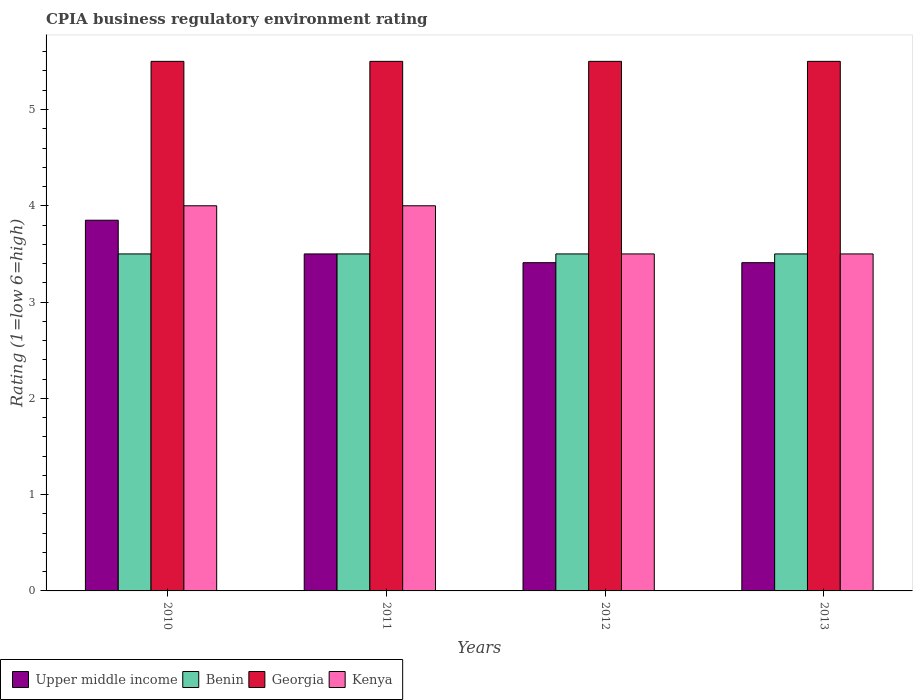Are the number of bars per tick equal to the number of legend labels?
Your answer should be compact. Yes. How many bars are there on the 3rd tick from the right?
Your answer should be very brief. 4. In how many cases, is the number of bars for a given year not equal to the number of legend labels?
Offer a terse response. 0. What is the CPIA rating in Upper middle income in 2010?
Your response must be concise. 3.85. Across all years, what is the maximum CPIA rating in Upper middle income?
Offer a terse response. 3.85. Across all years, what is the minimum CPIA rating in Georgia?
Give a very brief answer. 5.5. In which year was the CPIA rating in Upper middle income minimum?
Your answer should be compact. 2012. What is the total CPIA rating in Upper middle income in the graph?
Your answer should be very brief. 14.17. What is the difference between the CPIA rating in Upper middle income in 2010 and that in 2011?
Your answer should be compact. 0.35. What is the difference between the CPIA rating in Georgia in 2010 and the CPIA rating in Benin in 2013?
Your answer should be very brief. 2. What is the average CPIA rating in Kenya per year?
Your response must be concise. 3.75. In the year 2013, what is the difference between the CPIA rating in Georgia and CPIA rating in Upper middle income?
Ensure brevity in your answer.  2.09. In how many years, is the CPIA rating in Benin greater than 2.8?
Your answer should be compact. 4. Is the CPIA rating in Kenya in 2012 less than that in 2013?
Provide a succinct answer. No. Is the difference between the CPIA rating in Georgia in 2010 and 2013 greater than the difference between the CPIA rating in Upper middle income in 2010 and 2013?
Provide a short and direct response. No. What is the difference between the highest and the second highest CPIA rating in Benin?
Provide a succinct answer. 0. In how many years, is the CPIA rating in Georgia greater than the average CPIA rating in Georgia taken over all years?
Offer a terse response. 0. Is the sum of the CPIA rating in Upper middle income in 2010 and 2011 greater than the maximum CPIA rating in Kenya across all years?
Provide a short and direct response. Yes. What does the 4th bar from the left in 2012 represents?
Ensure brevity in your answer.  Kenya. What does the 1st bar from the right in 2012 represents?
Offer a terse response. Kenya. Where does the legend appear in the graph?
Your answer should be very brief. Bottom left. How many legend labels are there?
Keep it short and to the point. 4. What is the title of the graph?
Give a very brief answer. CPIA business regulatory environment rating. What is the Rating (1=low 6=high) of Upper middle income in 2010?
Keep it short and to the point. 3.85. What is the Rating (1=low 6=high) of Kenya in 2010?
Your answer should be compact. 4. What is the Rating (1=low 6=high) in Upper middle income in 2012?
Give a very brief answer. 3.41. What is the Rating (1=low 6=high) of Georgia in 2012?
Make the answer very short. 5.5. What is the Rating (1=low 6=high) of Kenya in 2012?
Provide a short and direct response. 3.5. What is the Rating (1=low 6=high) of Upper middle income in 2013?
Offer a terse response. 3.41. What is the Rating (1=low 6=high) in Benin in 2013?
Your response must be concise. 3.5. Across all years, what is the maximum Rating (1=low 6=high) of Upper middle income?
Keep it short and to the point. 3.85. Across all years, what is the maximum Rating (1=low 6=high) in Benin?
Keep it short and to the point. 3.5. Across all years, what is the minimum Rating (1=low 6=high) in Upper middle income?
Your response must be concise. 3.41. Across all years, what is the minimum Rating (1=low 6=high) of Kenya?
Keep it short and to the point. 3.5. What is the total Rating (1=low 6=high) of Upper middle income in the graph?
Give a very brief answer. 14.17. What is the total Rating (1=low 6=high) of Georgia in the graph?
Give a very brief answer. 22. What is the total Rating (1=low 6=high) of Kenya in the graph?
Offer a terse response. 15. What is the difference between the Rating (1=low 6=high) in Benin in 2010 and that in 2011?
Your answer should be compact. 0. What is the difference between the Rating (1=low 6=high) in Georgia in 2010 and that in 2011?
Offer a terse response. 0. What is the difference between the Rating (1=low 6=high) of Kenya in 2010 and that in 2011?
Keep it short and to the point. 0. What is the difference between the Rating (1=low 6=high) in Upper middle income in 2010 and that in 2012?
Offer a very short reply. 0.44. What is the difference between the Rating (1=low 6=high) in Benin in 2010 and that in 2012?
Keep it short and to the point. 0. What is the difference between the Rating (1=low 6=high) of Georgia in 2010 and that in 2012?
Offer a terse response. 0. What is the difference between the Rating (1=low 6=high) in Upper middle income in 2010 and that in 2013?
Offer a very short reply. 0.44. What is the difference between the Rating (1=low 6=high) of Kenya in 2010 and that in 2013?
Your response must be concise. 0.5. What is the difference between the Rating (1=low 6=high) of Upper middle income in 2011 and that in 2012?
Make the answer very short. 0.09. What is the difference between the Rating (1=low 6=high) in Georgia in 2011 and that in 2012?
Offer a terse response. 0. What is the difference between the Rating (1=low 6=high) of Upper middle income in 2011 and that in 2013?
Keep it short and to the point. 0.09. What is the difference between the Rating (1=low 6=high) in Benin in 2011 and that in 2013?
Your answer should be compact. 0. What is the difference between the Rating (1=low 6=high) in Georgia in 2011 and that in 2013?
Your response must be concise. 0. What is the difference between the Rating (1=low 6=high) of Kenya in 2011 and that in 2013?
Offer a very short reply. 0.5. What is the difference between the Rating (1=low 6=high) of Georgia in 2012 and that in 2013?
Keep it short and to the point. 0. What is the difference between the Rating (1=low 6=high) of Kenya in 2012 and that in 2013?
Provide a succinct answer. 0. What is the difference between the Rating (1=low 6=high) in Upper middle income in 2010 and the Rating (1=low 6=high) in Georgia in 2011?
Your answer should be compact. -1.65. What is the difference between the Rating (1=low 6=high) in Upper middle income in 2010 and the Rating (1=low 6=high) in Kenya in 2011?
Ensure brevity in your answer.  -0.15. What is the difference between the Rating (1=low 6=high) in Benin in 2010 and the Rating (1=low 6=high) in Kenya in 2011?
Offer a terse response. -0.5. What is the difference between the Rating (1=low 6=high) in Georgia in 2010 and the Rating (1=low 6=high) in Kenya in 2011?
Your response must be concise. 1.5. What is the difference between the Rating (1=low 6=high) of Upper middle income in 2010 and the Rating (1=low 6=high) of Benin in 2012?
Ensure brevity in your answer.  0.35. What is the difference between the Rating (1=low 6=high) in Upper middle income in 2010 and the Rating (1=low 6=high) in Georgia in 2012?
Provide a short and direct response. -1.65. What is the difference between the Rating (1=low 6=high) in Benin in 2010 and the Rating (1=low 6=high) in Kenya in 2012?
Your answer should be very brief. 0. What is the difference between the Rating (1=low 6=high) in Georgia in 2010 and the Rating (1=low 6=high) in Kenya in 2012?
Your answer should be very brief. 2. What is the difference between the Rating (1=low 6=high) in Upper middle income in 2010 and the Rating (1=low 6=high) in Georgia in 2013?
Offer a very short reply. -1.65. What is the difference between the Rating (1=low 6=high) in Upper middle income in 2010 and the Rating (1=low 6=high) in Kenya in 2013?
Your answer should be very brief. 0.35. What is the difference between the Rating (1=low 6=high) of Benin in 2010 and the Rating (1=low 6=high) of Georgia in 2013?
Give a very brief answer. -2. What is the difference between the Rating (1=low 6=high) in Upper middle income in 2011 and the Rating (1=low 6=high) in Benin in 2012?
Give a very brief answer. 0. What is the difference between the Rating (1=low 6=high) in Upper middle income in 2011 and the Rating (1=low 6=high) in Georgia in 2012?
Your response must be concise. -2. What is the difference between the Rating (1=low 6=high) in Benin in 2011 and the Rating (1=low 6=high) in Georgia in 2012?
Offer a very short reply. -2. What is the difference between the Rating (1=low 6=high) in Benin in 2011 and the Rating (1=low 6=high) in Kenya in 2012?
Provide a short and direct response. 0. What is the difference between the Rating (1=low 6=high) of Upper middle income in 2011 and the Rating (1=low 6=high) of Benin in 2013?
Make the answer very short. 0. What is the difference between the Rating (1=low 6=high) of Upper middle income in 2012 and the Rating (1=low 6=high) of Benin in 2013?
Your answer should be compact. -0.09. What is the difference between the Rating (1=low 6=high) of Upper middle income in 2012 and the Rating (1=low 6=high) of Georgia in 2013?
Keep it short and to the point. -2.09. What is the difference between the Rating (1=low 6=high) of Upper middle income in 2012 and the Rating (1=low 6=high) of Kenya in 2013?
Give a very brief answer. -0.09. What is the difference between the Rating (1=low 6=high) in Benin in 2012 and the Rating (1=low 6=high) in Kenya in 2013?
Give a very brief answer. 0. What is the average Rating (1=low 6=high) of Upper middle income per year?
Keep it short and to the point. 3.54. What is the average Rating (1=low 6=high) in Kenya per year?
Offer a terse response. 3.75. In the year 2010, what is the difference between the Rating (1=low 6=high) in Upper middle income and Rating (1=low 6=high) in Benin?
Your answer should be compact. 0.35. In the year 2010, what is the difference between the Rating (1=low 6=high) of Upper middle income and Rating (1=low 6=high) of Georgia?
Give a very brief answer. -1.65. In the year 2010, what is the difference between the Rating (1=low 6=high) of Benin and Rating (1=low 6=high) of Kenya?
Keep it short and to the point. -0.5. In the year 2011, what is the difference between the Rating (1=low 6=high) of Upper middle income and Rating (1=low 6=high) of Georgia?
Offer a terse response. -2. In the year 2011, what is the difference between the Rating (1=low 6=high) of Upper middle income and Rating (1=low 6=high) of Kenya?
Your answer should be compact. -0.5. In the year 2011, what is the difference between the Rating (1=low 6=high) in Benin and Rating (1=low 6=high) in Georgia?
Provide a short and direct response. -2. In the year 2011, what is the difference between the Rating (1=low 6=high) of Benin and Rating (1=low 6=high) of Kenya?
Offer a terse response. -0.5. In the year 2012, what is the difference between the Rating (1=low 6=high) of Upper middle income and Rating (1=low 6=high) of Benin?
Make the answer very short. -0.09. In the year 2012, what is the difference between the Rating (1=low 6=high) in Upper middle income and Rating (1=low 6=high) in Georgia?
Provide a succinct answer. -2.09. In the year 2012, what is the difference between the Rating (1=low 6=high) in Upper middle income and Rating (1=low 6=high) in Kenya?
Offer a very short reply. -0.09. In the year 2013, what is the difference between the Rating (1=low 6=high) of Upper middle income and Rating (1=low 6=high) of Benin?
Give a very brief answer. -0.09. In the year 2013, what is the difference between the Rating (1=low 6=high) in Upper middle income and Rating (1=low 6=high) in Georgia?
Provide a short and direct response. -2.09. In the year 2013, what is the difference between the Rating (1=low 6=high) in Upper middle income and Rating (1=low 6=high) in Kenya?
Ensure brevity in your answer.  -0.09. In the year 2013, what is the difference between the Rating (1=low 6=high) of Benin and Rating (1=low 6=high) of Kenya?
Give a very brief answer. 0. In the year 2013, what is the difference between the Rating (1=low 6=high) of Georgia and Rating (1=low 6=high) of Kenya?
Your answer should be very brief. 2. What is the ratio of the Rating (1=low 6=high) of Upper middle income in 2010 to that in 2011?
Keep it short and to the point. 1.1. What is the ratio of the Rating (1=low 6=high) of Georgia in 2010 to that in 2011?
Give a very brief answer. 1. What is the ratio of the Rating (1=low 6=high) of Upper middle income in 2010 to that in 2012?
Make the answer very short. 1.13. What is the ratio of the Rating (1=low 6=high) in Georgia in 2010 to that in 2012?
Give a very brief answer. 1. What is the ratio of the Rating (1=low 6=high) of Kenya in 2010 to that in 2012?
Keep it short and to the point. 1.14. What is the ratio of the Rating (1=low 6=high) of Upper middle income in 2010 to that in 2013?
Your answer should be very brief. 1.13. What is the ratio of the Rating (1=low 6=high) of Benin in 2010 to that in 2013?
Keep it short and to the point. 1. What is the ratio of the Rating (1=low 6=high) of Upper middle income in 2011 to that in 2012?
Provide a short and direct response. 1.03. What is the ratio of the Rating (1=low 6=high) in Georgia in 2011 to that in 2012?
Give a very brief answer. 1. What is the ratio of the Rating (1=low 6=high) of Kenya in 2011 to that in 2012?
Ensure brevity in your answer.  1.14. What is the ratio of the Rating (1=low 6=high) of Upper middle income in 2011 to that in 2013?
Your answer should be compact. 1.03. What is the ratio of the Rating (1=low 6=high) in Benin in 2011 to that in 2013?
Give a very brief answer. 1. What is the ratio of the Rating (1=low 6=high) of Georgia in 2011 to that in 2013?
Offer a very short reply. 1. What is the ratio of the Rating (1=low 6=high) of Georgia in 2012 to that in 2013?
Your answer should be compact. 1. What is the difference between the highest and the second highest Rating (1=low 6=high) in Upper middle income?
Offer a very short reply. 0.35. What is the difference between the highest and the second highest Rating (1=low 6=high) in Kenya?
Your answer should be very brief. 0. What is the difference between the highest and the lowest Rating (1=low 6=high) in Upper middle income?
Your response must be concise. 0.44. What is the difference between the highest and the lowest Rating (1=low 6=high) of Georgia?
Your response must be concise. 0. 